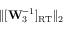<formula> <loc_0><loc_0><loc_500><loc_500>\| [ W _ { 3 } ^ { - 1 } ] _ { R T } \| _ { 2 }</formula> 